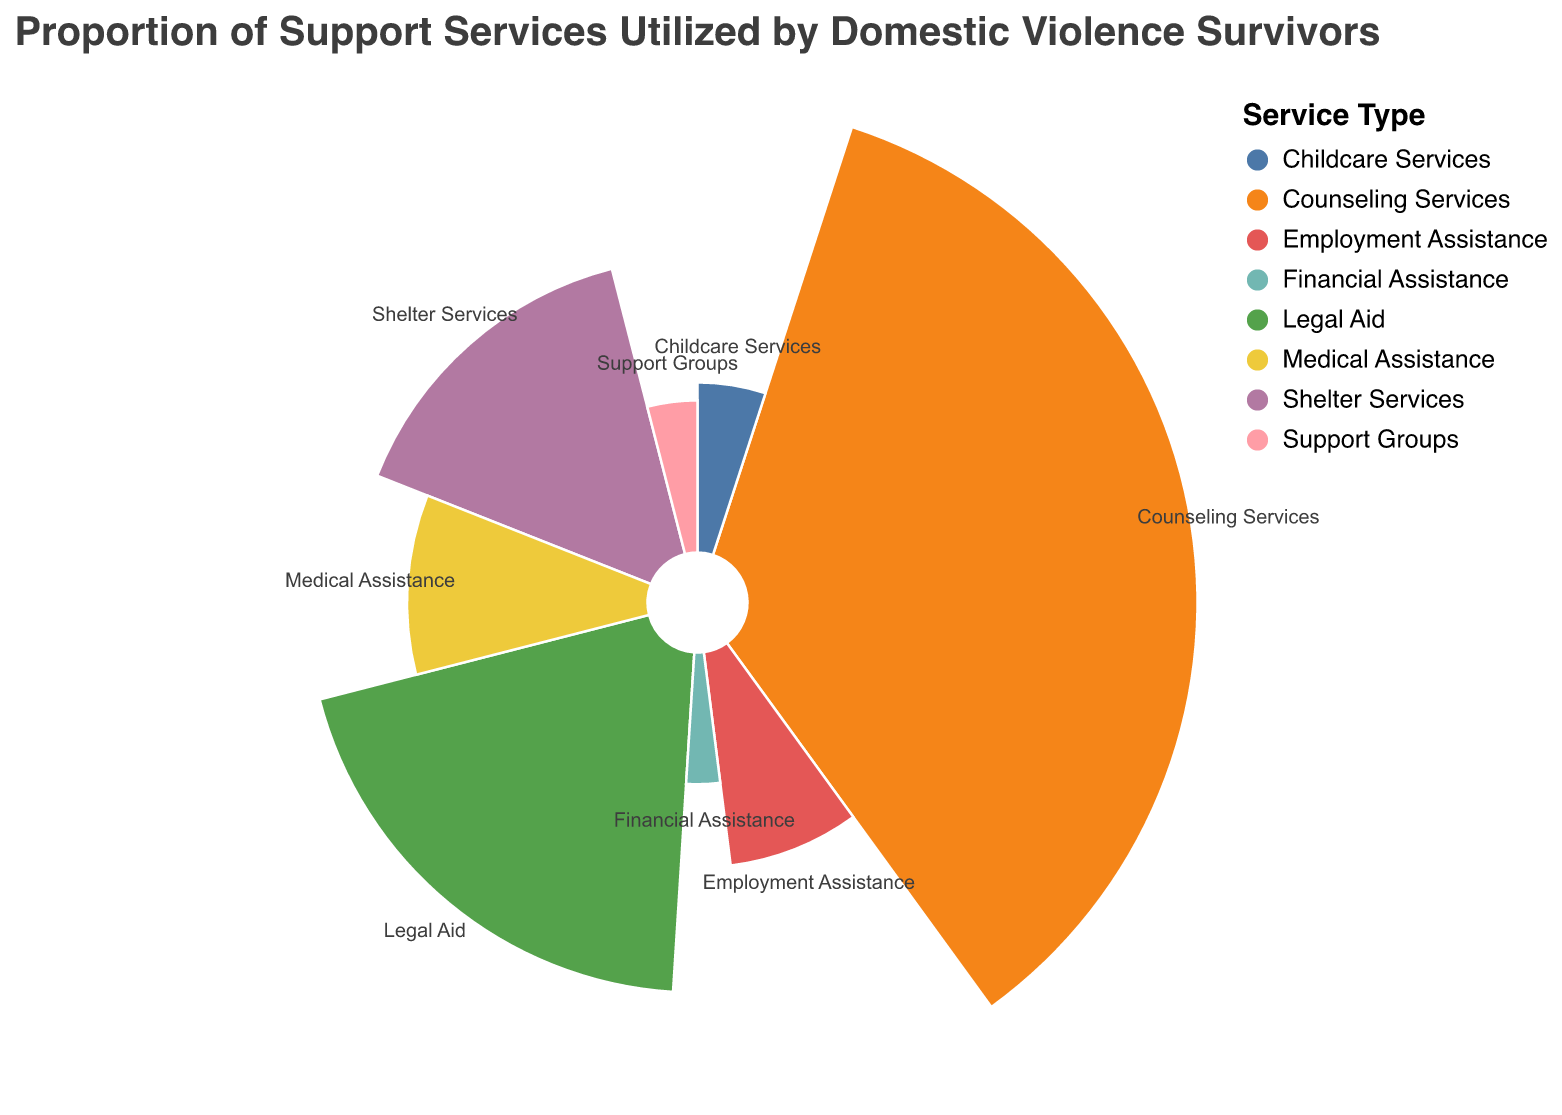What is the title of the chart? The title is displayed at the top of the chart and reads "Proportion of Support Services Utilized by Domestic Violence Survivors".
Answer: Proportion of Support Services Utilized by Domestic Violence Survivors Which service has the highest proportion of utilization? The chart segments show the proportions; the largest segment is labeled "Counseling Services".
Answer: Counseling Services What is the proportion of utilization for Legal Aid services? By looking at the legend and corresponding segment, Legal Aid services have a utilization proportion of 20%.
Answer: 20% How do Counseling Services and Employment Assistance compare in terms of proportion of utilization? Counseling Services shows a proportion of 35%, whereas Employment Assistance shows 8%. Comparing these, Counseling Services is higher.
Answer: Counseling Services are higher What is the combined proportion of utilization for Shelter Services and Medical Assistance? Adding the proportions from the segments, Shelter Services (15%) + Medical Assistance (10%) = 25%.
Answer: 25% Which service has the lowest proportion of utilization? The chart shows that Financial Assistance has the smallest segment, corresponding to 3%.
Answer: Financial Assistance What is the total proportion of utilization for Childcare Services and Support Groups? Summing the segments for Childcare Services (5%) and Support Groups (4%) gives 9%.
Answer: 9% What is the difference in utilization between the most and least utilized services? Counseling Services (35%) minus Financial Assistance (3%) equals a difference of 32%.
Answer: 32% Are any two services equal in proportion of utilization? By comparing segments, none have the same utilization proportion; each service differs.
Answer: No How many different types of services are represented in the chart? Counting each segment in the chart (as provided by the legend), there are 8 different services.
Answer: 8 